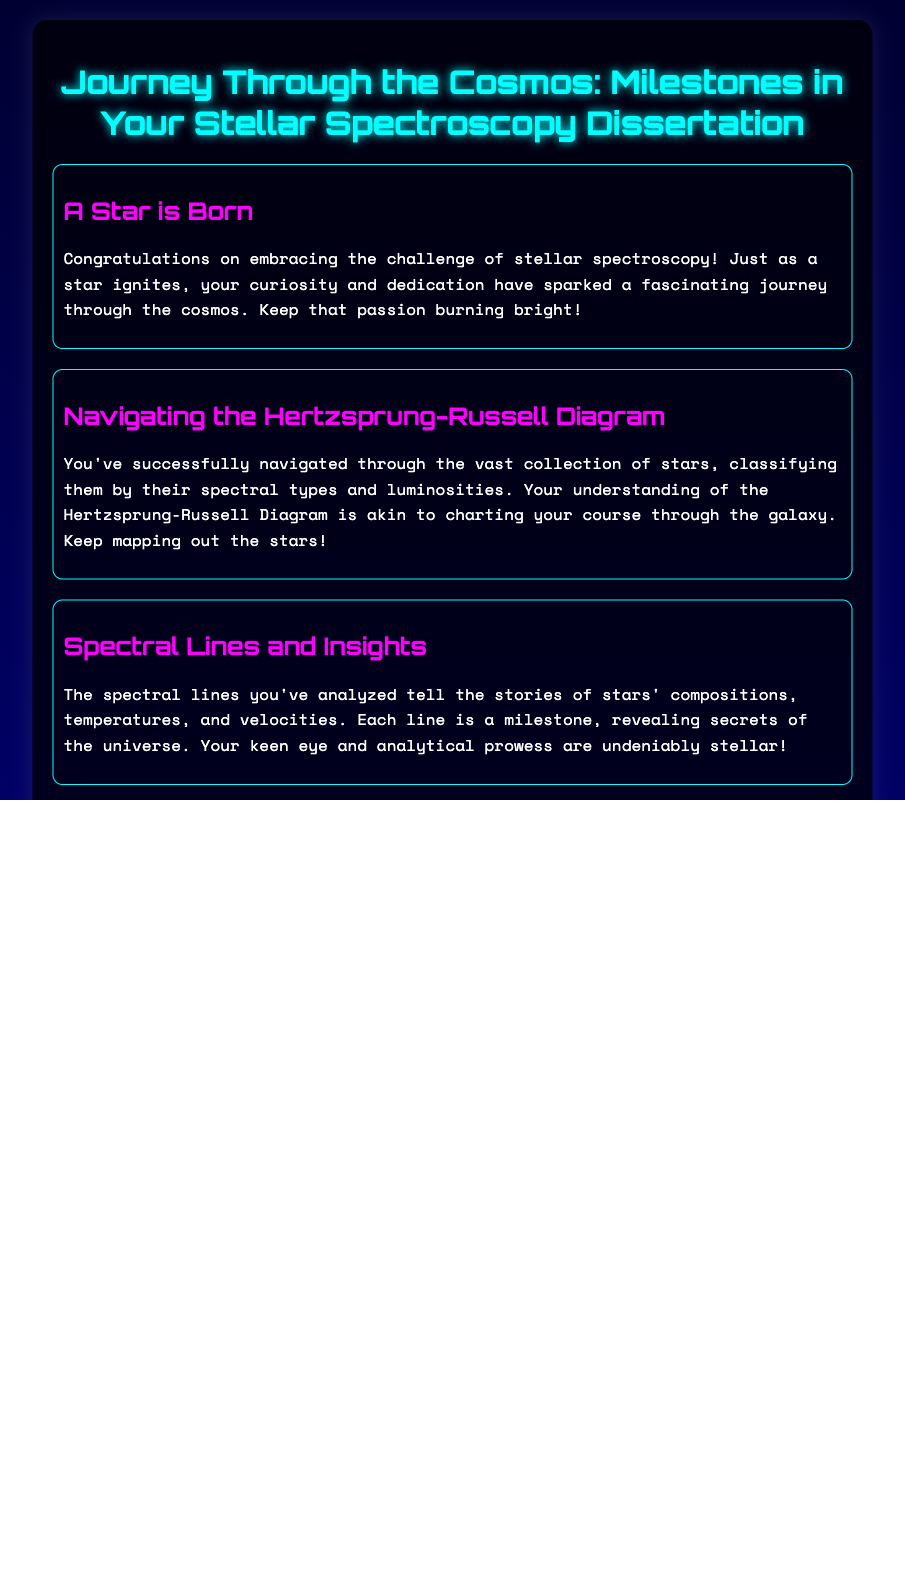What is the title of the card? The title of the card is prominently displayed at the top and it is "Journey Through the Cosmos: Milestones in Your Stellar Spectroscopy Dissertation."
Answer: Journey Through the Cosmos: Milestones in Your Stellar Spectroscopy Dissertation How many sections are there in the card? The card contains multiple sections each detailing different aspects of the dissertation journey, totaling six sections.
Answer: Six What color is the title text? The title text is highlighted in a specific color for emphasis, which is cyan.
Answer: Cyan What does the first section celebrate? The first section, titled "A Star is Born," celebrates the beginning of the journey in stellar spectroscopy.
Answer: The beginning of the journey in stellar spectroscopy What is the metaphor used for completed chapters? The completed chapters are metaphorically described as stars reaching the main sequence, symbolizing significant progress.
Answer: Stars reaching the main sequence What does the footer of the card wish for the recipient? The footer of the card offers encouragement for the recipient's ongoing journey, wishing for continued discoveries and wonders.
Answer: Continued discoveries and wonders What graphic element is used in the background? The background features animated stars, contributing to the cosmic theme of the greeting card.
Answer: Animated stars Which stage of stellar evolution is mentioned in the fifth section? The fifth section discusses the transition from red giants to supernovae, reflecting the deeper insights of the research.
Answer: Transition from red giants to supernovae What does the open book symbolize? The open book symbolizes knowledge and discovery, indicating the infinite possibilities ahead in the academic journey.
Answer: Knowledge and discovery 